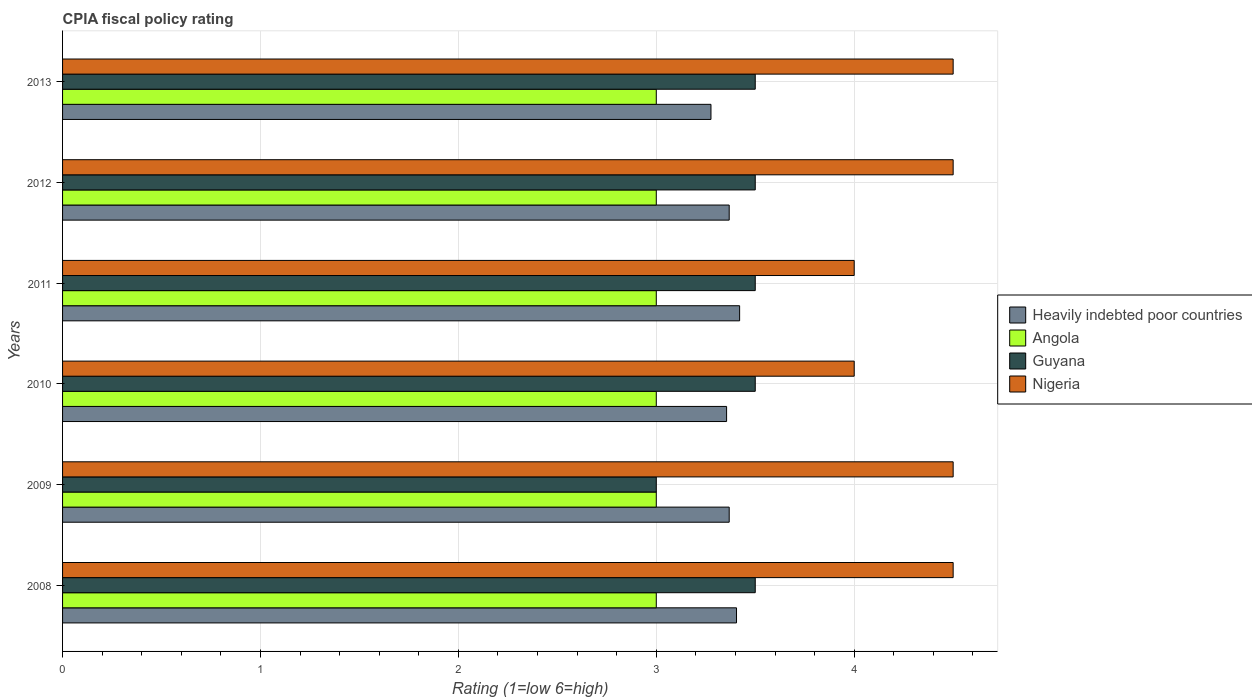How many different coloured bars are there?
Provide a short and direct response. 4. How many groups of bars are there?
Your answer should be compact. 6. Are the number of bars on each tick of the Y-axis equal?
Keep it short and to the point. Yes. How many bars are there on the 4th tick from the top?
Keep it short and to the point. 4. How many bars are there on the 4th tick from the bottom?
Your response must be concise. 4. What is the label of the 5th group of bars from the top?
Ensure brevity in your answer.  2009. Across all years, what is the maximum CPIA rating in Nigeria?
Offer a terse response. 4.5. Across all years, what is the minimum CPIA rating in Heavily indebted poor countries?
Give a very brief answer. 3.28. In which year was the CPIA rating in Guyana maximum?
Provide a short and direct response. 2008. In which year was the CPIA rating in Heavily indebted poor countries minimum?
Make the answer very short. 2013. What is the difference between the CPIA rating in Nigeria in 2010 and the CPIA rating in Heavily indebted poor countries in 2008?
Give a very brief answer. 0.59. What is the average CPIA rating in Nigeria per year?
Provide a succinct answer. 4.33. In the year 2008, what is the difference between the CPIA rating in Nigeria and CPIA rating in Heavily indebted poor countries?
Keep it short and to the point. 1.09. In how many years, is the CPIA rating in Nigeria greater than 2.4 ?
Ensure brevity in your answer.  6. What is the ratio of the CPIA rating in Guyana in 2011 to that in 2012?
Your response must be concise. 1. Is the CPIA rating in Guyana in 2012 less than that in 2013?
Give a very brief answer. No. Is the difference between the CPIA rating in Nigeria in 2008 and 2013 greater than the difference between the CPIA rating in Heavily indebted poor countries in 2008 and 2013?
Make the answer very short. No. What is the difference between the highest and the second highest CPIA rating in Heavily indebted poor countries?
Make the answer very short. 0.02. In how many years, is the CPIA rating in Angola greater than the average CPIA rating in Angola taken over all years?
Your answer should be compact. 0. Is it the case that in every year, the sum of the CPIA rating in Angola and CPIA rating in Guyana is greater than the sum of CPIA rating in Heavily indebted poor countries and CPIA rating in Nigeria?
Offer a very short reply. No. What does the 2nd bar from the top in 2012 represents?
Your answer should be compact. Guyana. What does the 1st bar from the bottom in 2013 represents?
Your answer should be very brief. Heavily indebted poor countries. Is it the case that in every year, the sum of the CPIA rating in Nigeria and CPIA rating in Angola is greater than the CPIA rating in Guyana?
Keep it short and to the point. Yes. Are all the bars in the graph horizontal?
Provide a succinct answer. Yes. What is the difference between two consecutive major ticks on the X-axis?
Your answer should be compact. 1. Are the values on the major ticks of X-axis written in scientific E-notation?
Your answer should be very brief. No. Does the graph contain any zero values?
Your answer should be very brief. No. Where does the legend appear in the graph?
Give a very brief answer. Center right. How many legend labels are there?
Offer a terse response. 4. How are the legend labels stacked?
Your answer should be very brief. Vertical. What is the title of the graph?
Your answer should be compact. CPIA fiscal policy rating. What is the Rating (1=low 6=high) of Heavily indebted poor countries in 2008?
Keep it short and to the point. 3.41. What is the Rating (1=low 6=high) in Angola in 2008?
Give a very brief answer. 3. What is the Rating (1=low 6=high) of Nigeria in 2008?
Offer a very short reply. 4.5. What is the Rating (1=low 6=high) in Heavily indebted poor countries in 2009?
Provide a short and direct response. 3.37. What is the Rating (1=low 6=high) of Heavily indebted poor countries in 2010?
Offer a very short reply. 3.36. What is the Rating (1=low 6=high) in Guyana in 2010?
Keep it short and to the point. 3.5. What is the Rating (1=low 6=high) in Heavily indebted poor countries in 2011?
Provide a succinct answer. 3.42. What is the Rating (1=low 6=high) in Nigeria in 2011?
Offer a very short reply. 4. What is the Rating (1=low 6=high) in Heavily indebted poor countries in 2012?
Offer a very short reply. 3.37. What is the Rating (1=low 6=high) of Angola in 2012?
Provide a succinct answer. 3. What is the Rating (1=low 6=high) of Guyana in 2012?
Offer a very short reply. 3.5. What is the Rating (1=low 6=high) of Heavily indebted poor countries in 2013?
Your answer should be compact. 3.28. What is the Rating (1=low 6=high) in Guyana in 2013?
Provide a short and direct response. 3.5. What is the Rating (1=low 6=high) of Nigeria in 2013?
Keep it short and to the point. 4.5. Across all years, what is the maximum Rating (1=low 6=high) of Heavily indebted poor countries?
Your answer should be very brief. 3.42. Across all years, what is the maximum Rating (1=low 6=high) in Nigeria?
Your response must be concise. 4.5. Across all years, what is the minimum Rating (1=low 6=high) of Heavily indebted poor countries?
Give a very brief answer. 3.28. Across all years, what is the minimum Rating (1=low 6=high) of Angola?
Offer a very short reply. 3. Across all years, what is the minimum Rating (1=low 6=high) in Guyana?
Provide a short and direct response. 3. Across all years, what is the minimum Rating (1=low 6=high) in Nigeria?
Offer a terse response. 4. What is the total Rating (1=low 6=high) of Heavily indebted poor countries in the graph?
Provide a succinct answer. 20.19. What is the difference between the Rating (1=low 6=high) in Heavily indebted poor countries in 2008 and that in 2009?
Provide a short and direct response. 0.04. What is the difference between the Rating (1=low 6=high) of Angola in 2008 and that in 2009?
Offer a terse response. 0. What is the difference between the Rating (1=low 6=high) in Guyana in 2008 and that in 2009?
Your answer should be very brief. 0.5. What is the difference between the Rating (1=low 6=high) of Heavily indebted poor countries in 2008 and that in 2010?
Provide a short and direct response. 0.05. What is the difference between the Rating (1=low 6=high) in Angola in 2008 and that in 2010?
Provide a short and direct response. 0. What is the difference between the Rating (1=low 6=high) in Guyana in 2008 and that in 2010?
Give a very brief answer. 0. What is the difference between the Rating (1=low 6=high) in Nigeria in 2008 and that in 2010?
Ensure brevity in your answer.  0.5. What is the difference between the Rating (1=low 6=high) in Heavily indebted poor countries in 2008 and that in 2011?
Give a very brief answer. -0.02. What is the difference between the Rating (1=low 6=high) of Nigeria in 2008 and that in 2011?
Provide a short and direct response. 0.5. What is the difference between the Rating (1=low 6=high) in Heavily indebted poor countries in 2008 and that in 2012?
Offer a terse response. 0.04. What is the difference between the Rating (1=low 6=high) of Angola in 2008 and that in 2012?
Provide a succinct answer. 0. What is the difference between the Rating (1=low 6=high) in Heavily indebted poor countries in 2008 and that in 2013?
Keep it short and to the point. 0.13. What is the difference between the Rating (1=low 6=high) of Angola in 2008 and that in 2013?
Offer a terse response. 0. What is the difference between the Rating (1=low 6=high) of Guyana in 2008 and that in 2013?
Your response must be concise. 0. What is the difference between the Rating (1=low 6=high) in Heavily indebted poor countries in 2009 and that in 2010?
Your answer should be compact. 0.01. What is the difference between the Rating (1=low 6=high) of Angola in 2009 and that in 2010?
Give a very brief answer. 0. What is the difference between the Rating (1=low 6=high) in Nigeria in 2009 and that in 2010?
Your response must be concise. 0.5. What is the difference between the Rating (1=low 6=high) in Heavily indebted poor countries in 2009 and that in 2011?
Provide a short and direct response. -0.05. What is the difference between the Rating (1=low 6=high) in Angola in 2009 and that in 2011?
Offer a terse response. 0. What is the difference between the Rating (1=low 6=high) in Guyana in 2009 and that in 2011?
Give a very brief answer. -0.5. What is the difference between the Rating (1=low 6=high) in Nigeria in 2009 and that in 2011?
Offer a terse response. 0.5. What is the difference between the Rating (1=low 6=high) in Heavily indebted poor countries in 2009 and that in 2012?
Provide a succinct answer. 0. What is the difference between the Rating (1=low 6=high) in Guyana in 2009 and that in 2012?
Your answer should be compact. -0.5. What is the difference between the Rating (1=low 6=high) of Heavily indebted poor countries in 2009 and that in 2013?
Make the answer very short. 0.09. What is the difference between the Rating (1=low 6=high) in Angola in 2009 and that in 2013?
Offer a very short reply. 0. What is the difference between the Rating (1=low 6=high) of Guyana in 2009 and that in 2013?
Your response must be concise. -0.5. What is the difference between the Rating (1=low 6=high) of Heavily indebted poor countries in 2010 and that in 2011?
Keep it short and to the point. -0.07. What is the difference between the Rating (1=low 6=high) of Angola in 2010 and that in 2011?
Keep it short and to the point. 0. What is the difference between the Rating (1=low 6=high) in Nigeria in 2010 and that in 2011?
Provide a short and direct response. 0. What is the difference between the Rating (1=low 6=high) in Heavily indebted poor countries in 2010 and that in 2012?
Provide a short and direct response. -0.01. What is the difference between the Rating (1=low 6=high) in Guyana in 2010 and that in 2012?
Your response must be concise. 0. What is the difference between the Rating (1=low 6=high) in Nigeria in 2010 and that in 2012?
Offer a very short reply. -0.5. What is the difference between the Rating (1=low 6=high) in Heavily indebted poor countries in 2010 and that in 2013?
Your response must be concise. 0.08. What is the difference between the Rating (1=low 6=high) in Angola in 2010 and that in 2013?
Provide a short and direct response. 0. What is the difference between the Rating (1=low 6=high) in Heavily indebted poor countries in 2011 and that in 2012?
Your answer should be very brief. 0.05. What is the difference between the Rating (1=low 6=high) of Angola in 2011 and that in 2012?
Offer a terse response. 0. What is the difference between the Rating (1=low 6=high) of Heavily indebted poor countries in 2011 and that in 2013?
Offer a very short reply. 0.14. What is the difference between the Rating (1=low 6=high) in Guyana in 2011 and that in 2013?
Give a very brief answer. 0. What is the difference between the Rating (1=low 6=high) of Heavily indebted poor countries in 2012 and that in 2013?
Your answer should be compact. 0.09. What is the difference between the Rating (1=low 6=high) of Guyana in 2012 and that in 2013?
Your answer should be compact. 0. What is the difference between the Rating (1=low 6=high) of Heavily indebted poor countries in 2008 and the Rating (1=low 6=high) of Angola in 2009?
Make the answer very short. 0.41. What is the difference between the Rating (1=low 6=high) in Heavily indebted poor countries in 2008 and the Rating (1=low 6=high) in Guyana in 2009?
Provide a short and direct response. 0.41. What is the difference between the Rating (1=low 6=high) in Heavily indebted poor countries in 2008 and the Rating (1=low 6=high) in Nigeria in 2009?
Offer a very short reply. -1.09. What is the difference between the Rating (1=low 6=high) in Angola in 2008 and the Rating (1=low 6=high) in Nigeria in 2009?
Offer a very short reply. -1.5. What is the difference between the Rating (1=low 6=high) in Guyana in 2008 and the Rating (1=low 6=high) in Nigeria in 2009?
Give a very brief answer. -1. What is the difference between the Rating (1=low 6=high) in Heavily indebted poor countries in 2008 and the Rating (1=low 6=high) in Angola in 2010?
Make the answer very short. 0.41. What is the difference between the Rating (1=low 6=high) of Heavily indebted poor countries in 2008 and the Rating (1=low 6=high) of Guyana in 2010?
Offer a terse response. -0.09. What is the difference between the Rating (1=low 6=high) of Heavily indebted poor countries in 2008 and the Rating (1=low 6=high) of Nigeria in 2010?
Make the answer very short. -0.59. What is the difference between the Rating (1=low 6=high) of Angola in 2008 and the Rating (1=low 6=high) of Guyana in 2010?
Your response must be concise. -0.5. What is the difference between the Rating (1=low 6=high) of Angola in 2008 and the Rating (1=low 6=high) of Nigeria in 2010?
Keep it short and to the point. -1. What is the difference between the Rating (1=low 6=high) of Guyana in 2008 and the Rating (1=low 6=high) of Nigeria in 2010?
Your answer should be very brief. -0.5. What is the difference between the Rating (1=low 6=high) of Heavily indebted poor countries in 2008 and the Rating (1=low 6=high) of Angola in 2011?
Make the answer very short. 0.41. What is the difference between the Rating (1=low 6=high) in Heavily indebted poor countries in 2008 and the Rating (1=low 6=high) in Guyana in 2011?
Keep it short and to the point. -0.09. What is the difference between the Rating (1=low 6=high) in Heavily indebted poor countries in 2008 and the Rating (1=low 6=high) in Nigeria in 2011?
Give a very brief answer. -0.59. What is the difference between the Rating (1=low 6=high) in Angola in 2008 and the Rating (1=low 6=high) in Nigeria in 2011?
Your answer should be compact. -1. What is the difference between the Rating (1=low 6=high) of Guyana in 2008 and the Rating (1=low 6=high) of Nigeria in 2011?
Make the answer very short. -0.5. What is the difference between the Rating (1=low 6=high) in Heavily indebted poor countries in 2008 and the Rating (1=low 6=high) in Angola in 2012?
Provide a succinct answer. 0.41. What is the difference between the Rating (1=low 6=high) of Heavily indebted poor countries in 2008 and the Rating (1=low 6=high) of Guyana in 2012?
Offer a very short reply. -0.09. What is the difference between the Rating (1=low 6=high) in Heavily indebted poor countries in 2008 and the Rating (1=low 6=high) in Nigeria in 2012?
Ensure brevity in your answer.  -1.09. What is the difference between the Rating (1=low 6=high) in Angola in 2008 and the Rating (1=low 6=high) in Nigeria in 2012?
Your answer should be very brief. -1.5. What is the difference between the Rating (1=low 6=high) of Guyana in 2008 and the Rating (1=low 6=high) of Nigeria in 2012?
Keep it short and to the point. -1. What is the difference between the Rating (1=low 6=high) of Heavily indebted poor countries in 2008 and the Rating (1=low 6=high) of Angola in 2013?
Your answer should be very brief. 0.41. What is the difference between the Rating (1=low 6=high) of Heavily indebted poor countries in 2008 and the Rating (1=low 6=high) of Guyana in 2013?
Keep it short and to the point. -0.09. What is the difference between the Rating (1=low 6=high) in Heavily indebted poor countries in 2008 and the Rating (1=low 6=high) in Nigeria in 2013?
Your response must be concise. -1.09. What is the difference between the Rating (1=low 6=high) of Guyana in 2008 and the Rating (1=low 6=high) of Nigeria in 2013?
Provide a short and direct response. -1. What is the difference between the Rating (1=low 6=high) in Heavily indebted poor countries in 2009 and the Rating (1=low 6=high) in Angola in 2010?
Provide a succinct answer. 0.37. What is the difference between the Rating (1=low 6=high) in Heavily indebted poor countries in 2009 and the Rating (1=low 6=high) in Guyana in 2010?
Offer a terse response. -0.13. What is the difference between the Rating (1=low 6=high) in Heavily indebted poor countries in 2009 and the Rating (1=low 6=high) in Nigeria in 2010?
Offer a terse response. -0.63. What is the difference between the Rating (1=low 6=high) in Angola in 2009 and the Rating (1=low 6=high) in Guyana in 2010?
Make the answer very short. -0.5. What is the difference between the Rating (1=low 6=high) in Angola in 2009 and the Rating (1=low 6=high) in Nigeria in 2010?
Provide a short and direct response. -1. What is the difference between the Rating (1=low 6=high) in Guyana in 2009 and the Rating (1=low 6=high) in Nigeria in 2010?
Your response must be concise. -1. What is the difference between the Rating (1=low 6=high) of Heavily indebted poor countries in 2009 and the Rating (1=low 6=high) of Angola in 2011?
Offer a terse response. 0.37. What is the difference between the Rating (1=low 6=high) of Heavily indebted poor countries in 2009 and the Rating (1=low 6=high) of Guyana in 2011?
Offer a very short reply. -0.13. What is the difference between the Rating (1=low 6=high) in Heavily indebted poor countries in 2009 and the Rating (1=low 6=high) in Nigeria in 2011?
Give a very brief answer. -0.63. What is the difference between the Rating (1=low 6=high) of Angola in 2009 and the Rating (1=low 6=high) of Guyana in 2011?
Your answer should be compact. -0.5. What is the difference between the Rating (1=low 6=high) of Angola in 2009 and the Rating (1=low 6=high) of Nigeria in 2011?
Ensure brevity in your answer.  -1. What is the difference between the Rating (1=low 6=high) in Heavily indebted poor countries in 2009 and the Rating (1=low 6=high) in Angola in 2012?
Your response must be concise. 0.37. What is the difference between the Rating (1=low 6=high) in Heavily indebted poor countries in 2009 and the Rating (1=low 6=high) in Guyana in 2012?
Offer a very short reply. -0.13. What is the difference between the Rating (1=low 6=high) in Heavily indebted poor countries in 2009 and the Rating (1=low 6=high) in Nigeria in 2012?
Provide a succinct answer. -1.13. What is the difference between the Rating (1=low 6=high) of Heavily indebted poor countries in 2009 and the Rating (1=low 6=high) of Angola in 2013?
Provide a short and direct response. 0.37. What is the difference between the Rating (1=low 6=high) of Heavily indebted poor countries in 2009 and the Rating (1=low 6=high) of Guyana in 2013?
Ensure brevity in your answer.  -0.13. What is the difference between the Rating (1=low 6=high) in Heavily indebted poor countries in 2009 and the Rating (1=low 6=high) in Nigeria in 2013?
Make the answer very short. -1.13. What is the difference between the Rating (1=low 6=high) in Angola in 2009 and the Rating (1=low 6=high) in Guyana in 2013?
Offer a terse response. -0.5. What is the difference between the Rating (1=low 6=high) of Guyana in 2009 and the Rating (1=low 6=high) of Nigeria in 2013?
Your answer should be compact. -1.5. What is the difference between the Rating (1=low 6=high) of Heavily indebted poor countries in 2010 and the Rating (1=low 6=high) of Angola in 2011?
Your answer should be compact. 0.36. What is the difference between the Rating (1=low 6=high) in Heavily indebted poor countries in 2010 and the Rating (1=low 6=high) in Guyana in 2011?
Give a very brief answer. -0.14. What is the difference between the Rating (1=low 6=high) in Heavily indebted poor countries in 2010 and the Rating (1=low 6=high) in Nigeria in 2011?
Your answer should be compact. -0.64. What is the difference between the Rating (1=low 6=high) in Angola in 2010 and the Rating (1=low 6=high) in Guyana in 2011?
Your answer should be compact. -0.5. What is the difference between the Rating (1=low 6=high) of Angola in 2010 and the Rating (1=low 6=high) of Nigeria in 2011?
Your answer should be compact. -1. What is the difference between the Rating (1=low 6=high) of Guyana in 2010 and the Rating (1=low 6=high) of Nigeria in 2011?
Provide a short and direct response. -0.5. What is the difference between the Rating (1=low 6=high) of Heavily indebted poor countries in 2010 and the Rating (1=low 6=high) of Angola in 2012?
Make the answer very short. 0.36. What is the difference between the Rating (1=low 6=high) in Heavily indebted poor countries in 2010 and the Rating (1=low 6=high) in Guyana in 2012?
Keep it short and to the point. -0.14. What is the difference between the Rating (1=low 6=high) of Heavily indebted poor countries in 2010 and the Rating (1=low 6=high) of Nigeria in 2012?
Ensure brevity in your answer.  -1.14. What is the difference between the Rating (1=low 6=high) of Angola in 2010 and the Rating (1=low 6=high) of Guyana in 2012?
Your answer should be very brief. -0.5. What is the difference between the Rating (1=low 6=high) of Angola in 2010 and the Rating (1=low 6=high) of Nigeria in 2012?
Offer a terse response. -1.5. What is the difference between the Rating (1=low 6=high) in Heavily indebted poor countries in 2010 and the Rating (1=low 6=high) in Angola in 2013?
Ensure brevity in your answer.  0.36. What is the difference between the Rating (1=low 6=high) in Heavily indebted poor countries in 2010 and the Rating (1=low 6=high) in Guyana in 2013?
Keep it short and to the point. -0.14. What is the difference between the Rating (1=low 6=high) in Heavily indebted poor countries in 2010 and the Rating (1=low 6=high) in Nigeria in 2013?
Provide a succinct answer. -1.14. What is the difference between the Rating (1=low 6=high) in Angola in 2010 and the Rating (1=low 6=high) in Guyana in 2013?
Ensure brevity in your answer.  -0.5. What is the difference between the Rating (1=low 6=high) of Angola in 2010 and the Rating (1=low 6=high) of Nigeria in 2013?
Offer a terse response. -1.5. What is the difference between the Rating (1=low 6=high) in Heavily indebted poor countries in 2011 and the Rating (1=low 6=high) in Angola in 2012?
Provide a succinct answer. 0.42. What is the difference between the Rating (1=low 6=high) in Heavily indebted poor countries in 2011 and the Rating (1=low 6=high) in Guyana in 2012?
Provide a succinct answer. -0.08. What is the difference between the Rating (1=low 6=high) of Heavily indebted poor countries in 2011 and the Rating (1=low 6=high) of Nigeria in 2012?
Offer a very short reply. -1.08. What is the difference between the Rating (1=low 6=high) in Angola in 2011 and the Rating (1=low 6=high) in Guyana in 2012?
Offer a terse response. -0.5. What is the difference between the Rating (1=low 6=high) in Guyana in 2011 and the Rating (1=low 6=high) in Nigeria in 2012?
Your response must be concise. -1. What is the difference between the Rating (1=low 6=high) in Heavily indebted poor countries in 2011 and the Rating (1=low 6=high) in Angola in 2013?
Provide a short and direct response. 0.42. What is the difference between the Rating (1=low 6=high) in Heavily indebted poor countries in 2011 and the Rating (1=low 6=high) in Guyana in 2013?
Provide a succinct answer. -0.08. What is the difference between the Rating (1=low 6=high) of Heavily indebted poor countries in 2011 and the Rating (1=low 6=high) of Nigeria in 2013?
Offer a terse response. -1.08. What is the difference between the Rating (1=low 6=high) in Angola in 2011 and the Rating (1=low 6=high) in Nigeria in 2013?
Offer a very short reply. -1.5. What is the difference between the Rating (1=low 6=high) of Heavily indebted poor countries in 2012 and the Rating (1=low 6=high) of Angola in 2013?
Provide a short and direct response. 0.37. What is the difference between the Rating (1=low 6=high) of Heavily indebted poor countries in 2012 and the Rating (1=low 6=high) of Guyana in 2013?
Offer a terse response. -0.13. What is the difference between the Rating (1=low 6=high) in Heavily indebted poor countries in 2012 and the Rating (1=low 6=high) in Nigeria in 2013?
Give a very brief answer. -1.13. What is the difference between the Rating (1=low 6=high) of Guyana in 2012 and the Rating (1=low 6=high) of Nigeria in 2013?
Your answer should be very brief. -1. What is the average Rating (1=low 6=high) in Heavily indebted poor countries per year?
Offer a very short reply. 3.37. What is the average Rating (1=low 6=high) in Angola per year?
Give a very brief answer. 3. What is the average Rating (1=low 6=high) in Guyana per year?
Your answer should be very brief. 3.42. What is the average Rating (1=low 6=high) in Nigeria per year?
Ensure brevity in your answer.  4.33. In the year 2008, what is the difference between the Rating (1=low 6=high) in Heavily indebted poor countries and Rating (1=low 6=high) in Angola?
Ensure brevity in your answer.  0.41. In the year 2008, what is the difference between the Rating (1=low 6=high) in Heavily indebted poor countries and Rating (1=low 6=high) in Guyana?
Make the answer very short. -0.09. In the year 2008, what is the difference between the Rating (1=low 6=high) of Heavily indebted poor countries and Rating (1=low 6=high) of Nigeria?
Your answer should be very brief. -1.09. In the year 2008, what is the difference between the Rating (1=low 6=high) of Angola and Rating (1=low 6=high) of Nigeria?
Make the answer very short. -1.5. In the year 2008, what is the difference between the Rating (1=low 6=high) of Guyana and Rating (1=low 6=high) of Nigeria?
Make the answer very short. -1. In the year 2009, what is the difference between the Rating (1=low 6=high) in Heavily indebted poor countries and Rating (1=low 6=high) in Angola?
Ensure brevity in your answer.  0.37. In the year 2009, what is the difference between the Rating (1=low 6=high) in Heavily indebted poor countries and Rating (1=low 6=high) in Guyana?
Provide a short and direct response. 0.37. In the year 2009, what is the difference between the Rating (1=low 6=high) of Heavily indebted poor countries and Rating (1=low 6=high) of Nigeria?
Provide a short and direct response. -1.13. In the year 2009, what is the difference between the Rating (1=low 6=high) in Angola and Rating (1=low 6=high) in Guyana?
Your answer should be compact. 0. In the year 2010, what is the difference between the Rating (1=low 6=high) in Heavily indebted poor countries and Rating (1=low 6=high) in Angola?
Your answer should be very brief. 0.36. In the year 2010, what is the difference between the Rating (1=low 6=high) of Heavily indebted poor countries and Rating (1=low 6=high) of Guyana?
Provide a short and direct response. -0.14. In the year 2010, what is the difference between the Rating (1=low 6=high) of Heavily indebted poor countries and Rating (1=low 6=high) of Nigeria?
Your answer should be very brief. -0.64. In the year 2010, what is the difference between the Rating (1=low 6=high) of Angola and Rating (1=low 6=high) of Guyana?
Provide a succinct answer. -0.5. In the year 2010, what is the difference between the Rating (1=low 6=high) of Angola and Rating (1=low 6=high) of Nigeria?
Provide a succinct answer. -1. In the year 2011, what is the difference between the Rating (1=low 6=high) of Heavily indebted poor countries and Rating (1=low 6=high) of Angola?
Give a very brief answer. 0.42. In the year 2011, what is the difference between the Rating (1=low 6=high) of Heavily indebted poor countries and Rating (1=low 6=high) of Guyana?
Provide a succinct answer. -0.08. In the year 2011, what is the difference between the Rating (1=low 6=high) of Heavily indebted poor countries and Rating (1=low 6=high) of Nigeria?
Your answer should be compact. -0.58. In the year 2011, what is the difference between the Rating (1=low 6=high) of Angola and Rating (1=low 6=high) of Guyana?
Your answer should be compact. -0.5. In the year 2011, what is the difference between the Rating (1=low 6=high) of Guyana and Rating (1=low 6=high) of Nigeria?
Ensure brevity in your answer.  -0.5. In the year 2012, what is the difference between the Rating (1=low 6=high) in Heavily indebted poor countries and Rating (1=low 6=high) in Angola?
Your response must be concise. 0.37. In the year 2012, what is the difference between the Rating (1=low 6=high) of Heavily indebted poor countries and Rating (1=low 6=high) of Guyana?
Offer a terse response. -0.13. In the year 2012, what is the difference between the Rating (1=low 6=high) in Heavily indebted poor countries and Rating (1=low 6=high) in Nigeria?
Offer a very short reply. -1.13. In the year 2012, what is the difference between the Rating (1=low 6=high) of Angola and Rating (1=low 6=high) of Nigeria?
Give a very brief answer. -1.5. In the year 2013, what is the difference between the Rating (1=low 6=high) in Heavily indebted poor countries and Rating (1=low 6=high) in Angola?
Provide a short and direct response. 0.28. In the year 2013, what is the difference between the Rating (1=low 6=high) in Heavily indebted poor countries and Rating (1=low 6=high) in Guyana?
Provide a short and direct response. -0.22. In the year 2013, what is the difference between the Rating (1=low 6=high) of Heavily indebted poor countries and Rating (1=low 6=high) of Nigeria?
Offer a terse response. -1.22. In the year 2013, what is the difference between the Rating (1=low 6=high) in Angola and Rating (1=low 6=high) in Guyana?
Ensure brevity in your answer.  -0.5. In the year 2013, what is the difference between the Rating (1=low 6=high) in Angola and Rating (1=low 6=high) in Nigeria?
Provide a short and direct response. -1.5. What is the ratio of the Rating (1=low 6=high) of Heavily indebted poor countries in 2008 to that in 2009?
Keep it short and to the point. 1.01. What is the ratio of the Rating (1=low 6=high) in Guyana in 2008 to that in 2009?
Provide a succinct answer. 1.17. What is the ratio of the Rating (1=low 6=high) of Nigeria in 2008 to that in 2009?
Make the answer very short. 1. What is the ratio of the Rating (1=low 6=high) of Heavily indebted poor countries in 2008 to that in 2010?
Your response must be concise. 1.01. What is the ratio of the Rating (1=low 6=high) in Nigeria in 2008 to that in 2010?
Your answer should be very brief. 1.12. What is the ratio of the Rating (1=low 6=high) in Heavily indebted poor countries in 2008 to that in 2011?
Provide a succinct answer. 1. What is the ratio of the Rating (1=low 6=high) of Angola in 2008 to that in 2011?
Make the answer very short. 1. What is the ratio of the Rating (1=low 6=high) in Guyana in 2008 to that in 2011?
Make the answer very short. 1. What is the ratio of the Rating (1=low 6=high) in Nigeria in 2008 to that in 2011?
Offer a terse response. 1.12. What is the ratio of the Rating (1=low 6=high) in Guyana in 2008 to that in 2012?
Provide a short and direct response. 1. What is the ratio of the Rating (1=low 6=high) in Heavily indebted poor countries in 2008 to that in 2013?
Provide a succinct answer. 1.04. What is the ratio of the Rating (1=low 6=high) in Angola in 2008 to that in 2013?
Your response must be concise. 1. What is the ratio of the Rating (1=low 6=high) of Guyana in 2008 to that in 2013?
Your answer should be compact. 1. What is the ratio of the Rating (1=low 6=high) of Heavily indebted poor countries in 2009 to that in 2010?
Offer a terse response. 1. What is the ratio of the Rating (1=low 6=high) in Angola in 2009 to that in 2010?
Make the answer very short. 1. What is the ratio of the Rating (1=low 6=high) of Heavily indebted poor countries in 2009 to that in 2011?
Your answer should be very brief. 0.98. What is the ratio of the Rating (1=low 6=high) of Angola in 2009 to that in 2011?
Offer a terse response. 1. What is the ratio of the Rating (1=low 6=high) of Nigeria in 2009 to that in 2011?
Your response must be concise. 1.12. What is the ratio of the Rating (1=low 6=high) in Angola in 2009 to that in 2012?
Make the answer very short. 1. What is the ratio of the Rating (1=low 6=high) of Nigeria in 2009 to that in 2012?
Offer a terse response. 1. What is the ratio of the Rating (1=low 6=high) in Heavily indebted poor countries in 2009 to that in 2013?
Your answer should be compact. 1.03. What is the ratio of the Rating (1=low 6=high) in Heavily indebted poor countries in 2010 to that in 2011?
Ensure brevity in your answer.  0.98. What is the ratio of the Rating (1=low 6=high) in Guyana in 2010 to that in 2011?
Make the answer very short. 1. What is the ratio of the Rating (1=low 6=high) of Nigeria in 2010 to that in 2011?
Give a very brief answer. 1. What is the ratio of the Rating (1=low 6=high) of Nigeria in 2010 to that in 2012?
Keep it short and to the point. 0.89. What is the ratio of the Rating (1=low 6=high) of Heavily indebted poor countries in 2010 to that in 2013?
Give a very brief answer. 1.02. What is the ratio of the Rating (1=low 6=high) of Angola in 2010 to that in 2013?
Your answer should be compact. 1. What is the ratio of the Rating (1=low 6=high) of Heavily indebted poor countries in 2011 to that in 2012?
Keep it short and to the point. 1.02. What is the ratio of the Rating (1=low 6=high) of Guyana in 2011 to that in 2012?
Provide a short and direct response. 1. What is the ratio of the Rating (1=low 6=high) in Nigeria in 2011 to that in 2012?
Your answer should be compact. 0.89. What is the ratio of the Rating (1=low 6=high) of Heavily indebted poor countries in 2011 to that in 2013?
Offer a terse response. 1.04. What is the ratio of the Rating (1=low 6=high) of Angola in 2011 to that in 2013?
Your answer should be very brief. 1. What is the ratio of the Rating (1=low 6=high) of Heavily indebted poor countries in 2012 to that in 2013?
Make the answer very short. 1.03. What is the ratio of the Rating (1=low 6=high) in Nigeria in 2012 to that in 2013?
Provide a short and direct response. 1. What is the difference between the highest and the second highest Rating (1=low 6=high) in Heavily indebted poor countries?
Provide a succinct answer. 0.02. What is the difference between the highest and the second highest Rating (1=low 6=high) of Guyana?
Your answer should be compact. 0. What is the difference between the highest and the second highest Rating (1=low 6=high) in Nigeria?
Ensure brevity in your answer.  0. What is the difference between the highest and the lowest Rating (1=low 6=high) in Heavily indebted poor countries?
Offer a very short reply. 0.14. What is the difference between the highest and the lowest Rating (1=low 6=high) of Angola?
Give a very brief answer. 0. What is the difference between the highest and the lowest Rating (1=low 6=high) in Guyana?
Provide a short and direct response. 0.5. What is the difference between the highest and the lowest Rating (1=low 6=high) in Nigeria?
Offer a terse response. 0.5. 